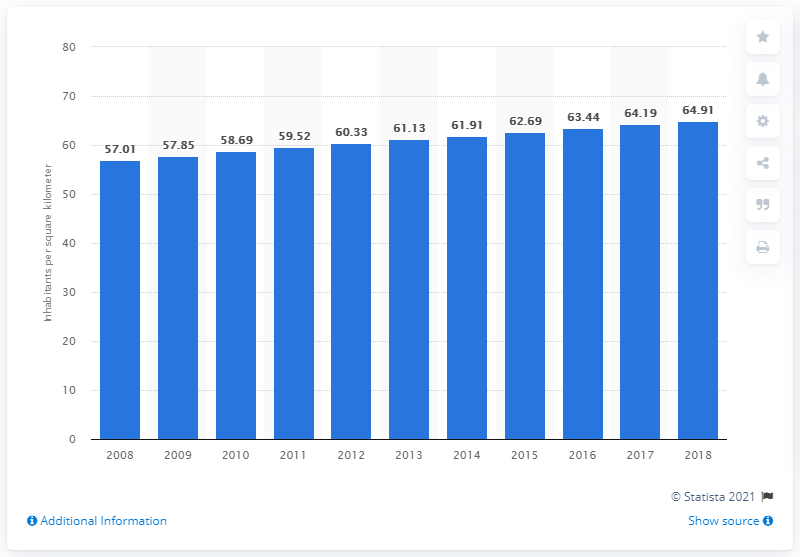Give some essential details in this illustration. In 2018, Mexico's population density was estimated to be approximately 64.91 people per square kilometer. 